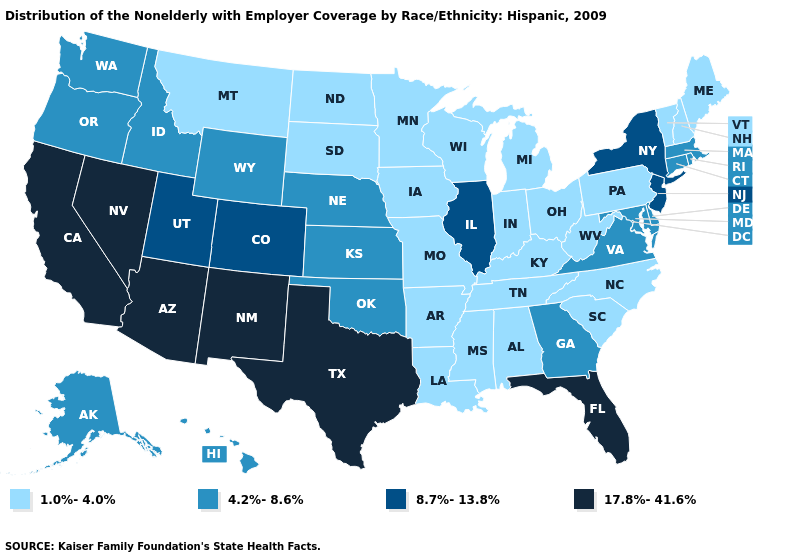Does Arizona have the highest value in the USA?
Quick response, please. Yes. Name the states that have a value in the range 4.2%-8.6%?
Concise answer only. Alaska, Connecticut, Delaware, Georgia, Hawaii, Idaho, Kansas, Maryland, Massachusetts, Nebraska, Oklahoma, Oregon, Rhode Island, Virginia, Washington, Wyoming. Does North Carolina have a lower value than Michigan?
Short answer required. No. Name the states that have a value in the range 4.2%-8.6%?
Give a very brief answer. Alaska, Connecticut, Delaware, Georgia, Hawaii, Idaho, Kansas, Maryland, Massachusetts, Nebraska, Oklahoma, Oregon, Rhode Island, Virginia, Washington, Wyoming. Name the states that have a value in the range 8.7%-13.8%?
Short answer required. Colorado, Illinois, New Jersey, New York, Utah. What is the lowest value in states that border Iowa?
Write a very short answer. 1.0%-4.0%. Name the states that have a value in the range 17.8%-41.6%?
Keep it brief. Arizona, California, Florida, Nevada, New Mexico, Texas. Name the states that have a value in the range 17.8%-41.6%?
Short answer required. Arizona, California, Florida, Nevada, New Mexico, Texas. Among the states that border Georgia , does Florida have the highest value?
Give a very brief answer. Yes. Among the states that border Indiana , does Illinois have the lowest value?
Concise answer only. No. Does Ohio have the lowest value in the MidWest?
Answer briefly. Yes. What is the value of Colorado?
Concise answer only. 8.7%-13.8%. Name the states that have a value in the range 4.2%-8.6%?
Answer briefly. Alaska, Connecticut, Delaware, Georgia, Hawaii, Idaho, Kansas, Maryland, Massachusetts, Nebraska, Oklahoma, Oregon, Rhode Island, Virginia, Washington, Wyoming. Among the states that border Nevada , does California have the highest value?
Answer briefly. Yes. Which states have the highest value in the USA?
Give a very brief answer. Arizona, California, Florida, Nevada, New Mexico, Texas. 